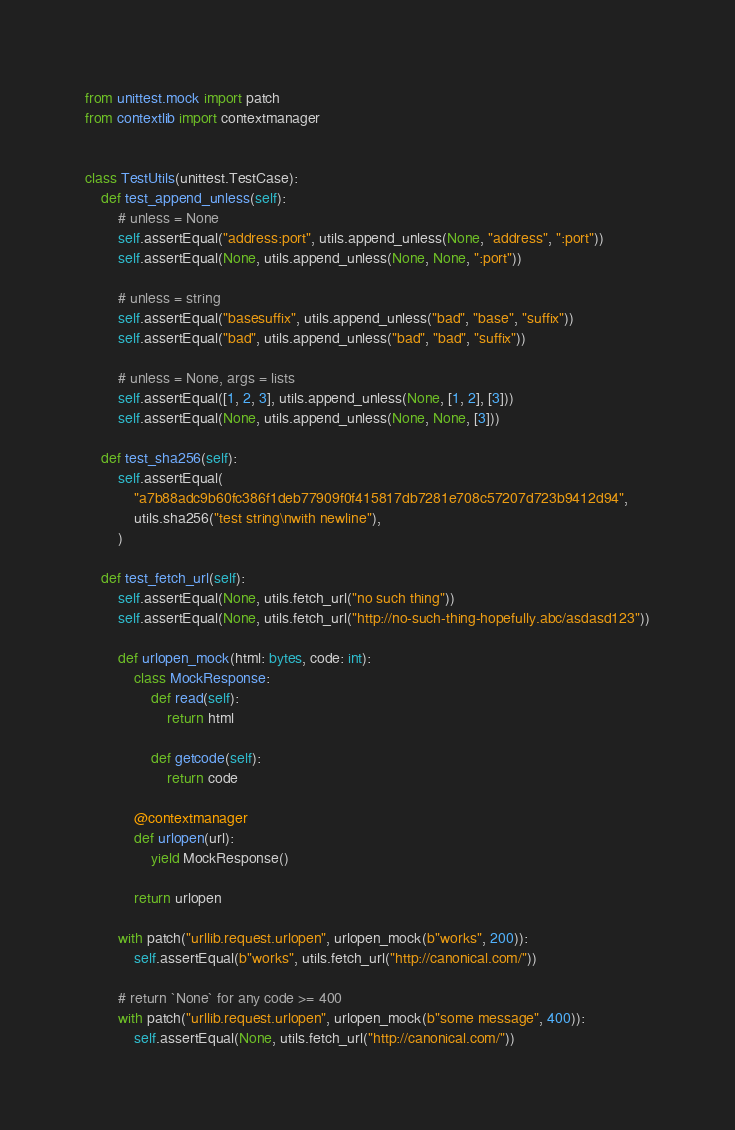Convert code to text. <code><loc_0><loc_0><loc_500><loc_500><_Python_>from unittest.mock import patch
from contextlib import contextmanager


class TestUtils(unittest.TestCase):
    def test_append_unless(self):
        # unless = None
        self.assertEqual("address:port", utils.append_unless(None, "address", ":port"))
        self.assertEqual(None, utils.append_unless(None, None, ":port"))

        # unless = string
        self.assertEqual("basesuffix", utils.append_unless("bad", "base", "suffix"))
        self.assertEqual("bad", utils.append_unless("bad", "bad", "suffix"))

        # unless = None, args = lists
        self.assertEqual([1, 2, 3], utils.append_unless(None, [1, 2], [3]))
        self.assertEqual(None, utils.append_unless(None, None, [3]))

    def test_sha256(self):
        self.assertEqual(
            "a7b88adc9b60fc386f1deb77909f0f415817db7281e708c57207d723b9412d94",
            utils.sha256("test string\nwith newline"),
        )

    def test_fetch_url(self):
        self.assertEqual(None, utils.fetch_url("no such thing"))
        self.assertEqual(None, utils.fetch_url("http://no-such-thing-hopefully.abc/asdasd123"))

        def urlopen_mock(html: bytes, code: int):
            class MockResponse:
                def read(self):
                    return html

                def getcode(self):
                    return code

            @contextmanager
            def urlopen(url):
                yield MockResponse()

            return urlopen

        with patch("urllib.request.urlopen", urlopen_mock(b"works", 200)):
            self.assertEqual(b"works", utils.fetch_url("http://canonical.com/"))

        # return `None` for any code >= 400
        with patch("urllib.request.urlopen", urlopen_mock(b"some message", 400)):
            self.assertEqual(None, utils.fetch_url("http://canonical.com/"))
</code> 